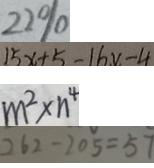Convert formula to latex. <formula><loc_0><loc_0><loc_500><loc_500>2 2 \% 
 1 5 x + 5 - 1 6 x - 4 
 m ^ { 2 } \times n ^ { 4 } 
 2 6 2 - 2 0 5 = 5 7</formula> 